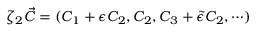<formula> <loc_0><loc_0><loc_500><loc_500>\zeta _ { 2 } \vec { C } = ( C _ { 1 } + \epsilon C _ { 2 } , C _ { 2 } , C _ { 3 } + \tilde { \epsilon } C _ { 2 } , \cdots )</formula> 